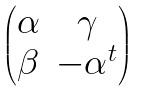Convert formula to latex. <formula><loc_0><loc_0><loc_500><loc_500>\begin{pmatrix} \alpha & \gamma \\ \beta & - \alpha ^ { t } \end{pmatrix}</formula> 